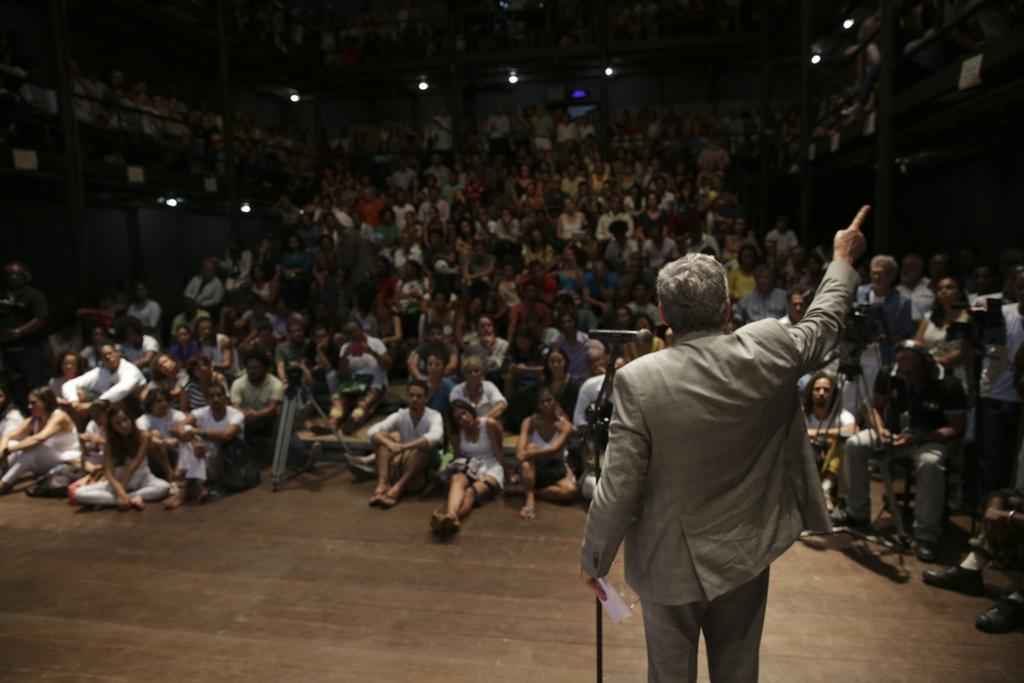What is the man in the image doing? The man is standing in front of a mic. What can be seen in the background of the image? There are people sitting on stairs and chairs in the background. What is visible at the top of the image? There are lights visible at the top of the image. What type of can does the man offer to the audience in the image? There is no can present in the image, and the man is not offering anything to the audience. 